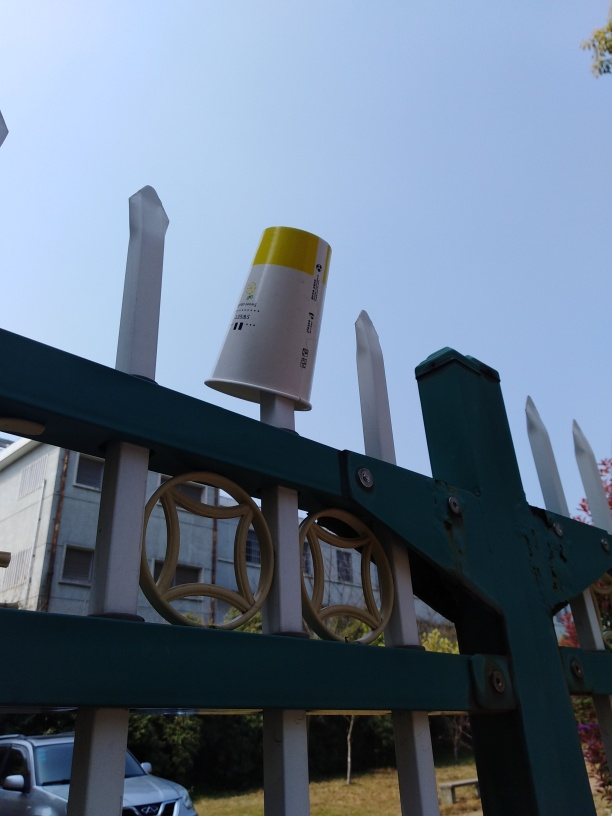How does the composition of the image influence its aesthetic quality? The composition of this image creates a balance between man-made structures and the natural environment. The vertical lines of the fence posts counteract the horizontal lines of the railing and the cup adds a point of interest. Although the scene is somewhat ordinary, the framing gives it a deliberate quality, with the contrasting textures and colors providing visual interest. The cup's placement at a high point on the fence introduces an unusual element that disrupts the otherwise orderly scene, which may provoke reflection on the interplay between human existence and the environment. 